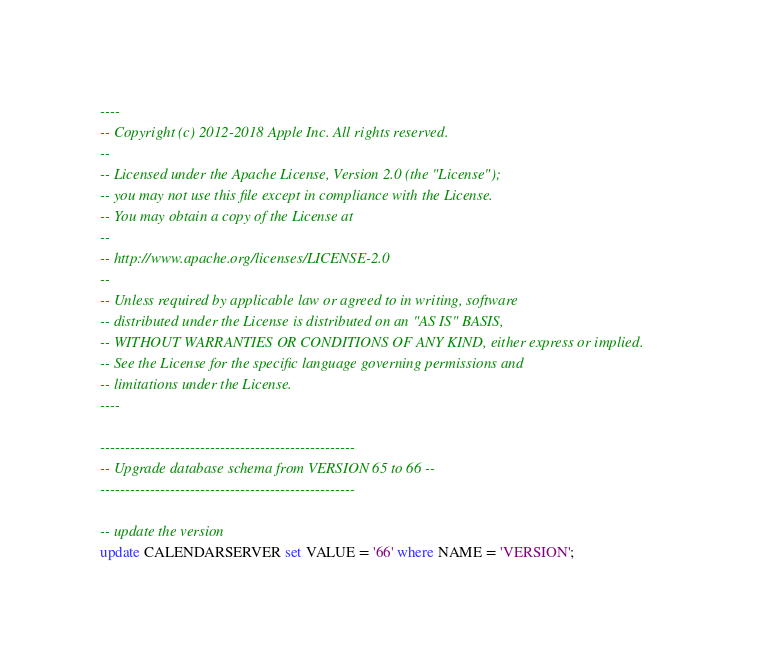<code> <loc_0><loc_0><loc_500><loc_500><_SQL_>----
-- Copyright (c) 2012-2018 Apple Inc. All rights reserved.
--
-- Licensed under the Apache License, Version 2.0 (the "License");
-- you may not use this file except in compliance with the License.
-- You may obtain a copy of the License at
--
-- http://www.apache.org/licenses/LICENSE-2.0
--
-- Unless required by applicable law or agreed to in writing, software
-- distributed under the License is distributed on an "AS IS" BASIS,
-- WITHOUT WARRANTIES OR CONDITIONS OF ANY KIND, either express or implied.
-- See the License for the specific language governing permissions and
-- limitations under the License.
----

---------------------------------------------------
-- Upgrade database schema from VERSION 65 to 66 --
---------------------------------------------------

-- update the version
update CALENDARSERVER set VALUE = '66' where NAME = 'VERSION';
</code> 